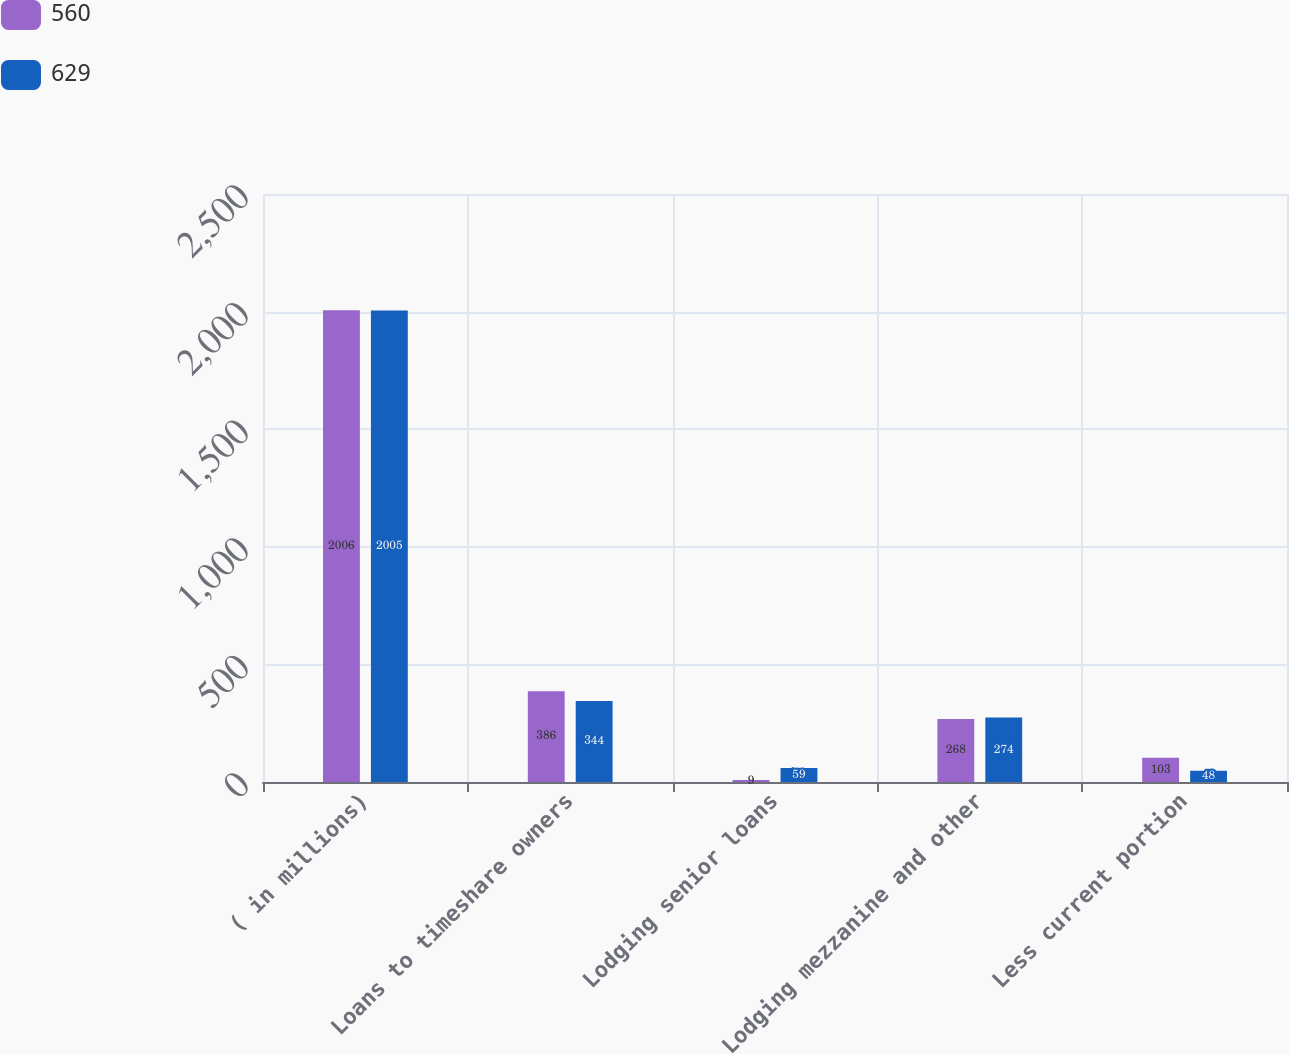Convert chart to OTSL. <chart><loc_0><loc_0><loc_500><loc_500><stacked_bar_chart><ecel><fcel>( in millions)<fcel>Loans to timeshare owners<fcel>Lodging senior loans<fcel>Lodging mezzanine and other<fcel>Less current portion<nl><fcel>560<fcel>2006<fcel>386<fcel>9<fcel>268<fcel>103<nl><fcel>629<fcel>2005<fcel>344<fcel>59<fcel>274<fcel>48<nl></chart> 